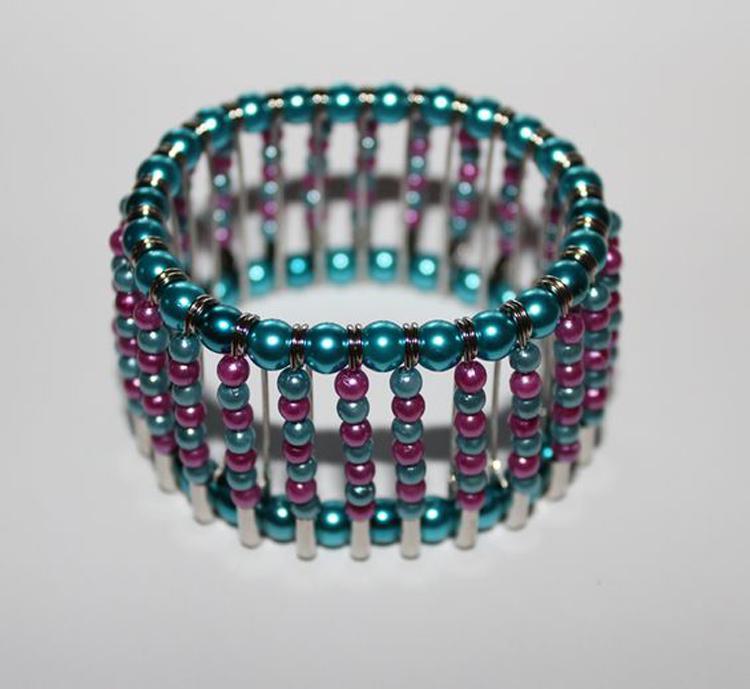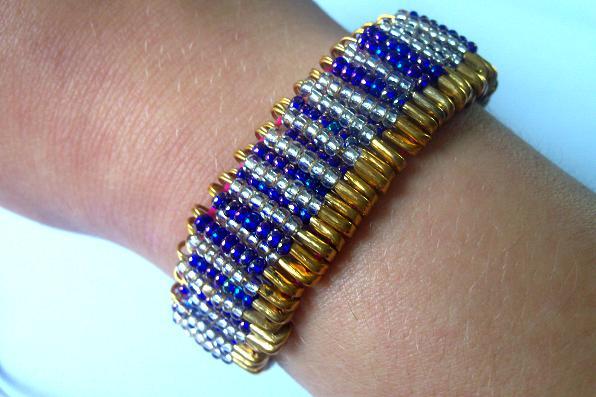The first image is the image on the left, the second image is the image on the right. Given the left and right images, does the statement "In one image, a bracelet made out of safety pins and blue and silver beads is on the arm of a person." hold true? Answer yes or no. Yes. The first image is the image on the left, the second image is the image on the right. Assess this claim about the two images: "A bracelet is worn by a person.". Correct or not? Answer yes or no. Yes. 